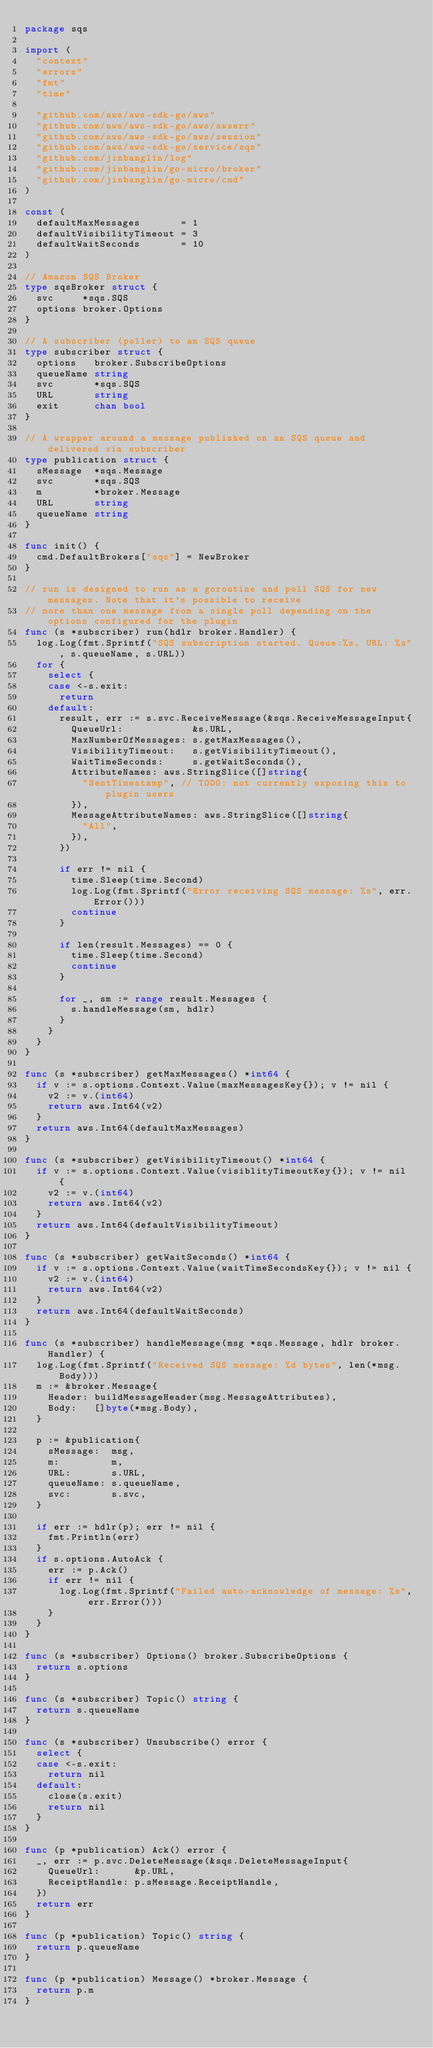Convert code to text. <code><loc_0><loc_0><loc_500><loc_500><_Go_>package sqs

import (
	"context"
	"errors"
	"fmt"
	"time"

	"github.com/aws/aws-sdk-go/aws"
	"github.com/aws/aws-sdk-go/aws/awserr"
	"github.com/aws/aws-sdk-go/aws/session"
	"github.com/aws/aws-sdk-go/service/sqs"
	"github.com/jinbanglin/log"
	"github.com/jinbanglin/go-micro/broker"
	"github.com/jinbanglin/go-micro/cmd"
)

const (
	defaultMaxMessages       = 1
	defaultVisibilityTimeout = 3
	defaultWaitSeconds       = 10
)

// Amazon SQS Broker
type sqsBroker struct {
	svc     *sqs.SQS
	options broker.Options
}

// A subscriber (poller) to an SQS queue
type subscriber struct {
	options   broker.SubscribeOptions
	queueName string
	svc       *sqs.SQS
	URL       string
	exit      chan bool
}

// A wrapper around a message published on an SQS queue and delivered via subscriber
type publication struct {
	sMessage  *sqs.Message
	svc       *sqs.SQS
	m         *broker.Message
	URL       string
	queueName string
}

func init() {
	cmd.DefaultBrokers["sqs"] = NewBroker
}

// run is designed to run as a goroutine and poll SQS for new messages. Note that it's possible to receive
// more than one message from a single poll depending on the options configured for the plugin
func (s *subscriber) run(hdlr broker.Handler) {
	log.Log(fmt.Sprintf("SQS subscription started. Queue:%s, URL: %s", s.queueName, s.URL))
	for {
		select {
		case <-s.exit:
			return
		default:
			result, err := s.svc.ReceiveMessage(&sqs.ReceiveMessageInput{
				QueueUrl:            &s.URL,
				MaxNumberOfMessages: s.getMaxMessages(),
				VisibilityTimeout:   s.getVisibilityTimeout(),
				WaitTimeSeconds:     s.getWaitSeconds(),
				AttributeNames: aws.StringSlice([]string{
					"SentTimestamp", // TODO: not currently exposing this to plugin users
				}),
				MessageAttributeNames: aws.StringSlice([]string{
					"All",
				}),
			})

			if err != nil {
				time.Sleep(time.Second)
				log.Log(fmt.Sprintf("Error receiving SQS message: %s", err.Error()))
				continue
			}

			if len(result.Messages) == 0 {
				time.Sleep(time.Second)
				continue
			}

			for _, sm := range result.Messages {
				s.handleMessage(sm, hdlr)
			}
		}
	}
}

func (s *subscriber) getMaxMessages() *int64 {
	if v := s.options.Context.Value(maxMessagesKey{}); v != nil {
		v2 := v.(int64)
		return aws.Int64(v2)
	}
	return aws.Int64(defaultMaxMessages)
}

func (s *subscriber) getVisibilityTimeout() *int64 {
	if v := s.options.Context.Value(visiblityTimeoutKey{}); v != nil {
		v2 := v.(int64)
		return aws.Int64(v2)
	}
	return aws.Int64(defaultVisibilityTimeout)
}

func (s *subscriber) getWaitSeconds() *int64 {
	if v := s.options.Context.Value(waitTimeSecondsKey{}); v != nil {
		v2 := v.(int64)
		return aws.Int64(v2)
	}
	return aws.Int64(defaultWaitSeconds)
}

func (s *subscriber) handleMessage(msg *sqs.Message, hdlr broker.Handler) {
	log.Log(fmt.Sprintf("Received SQS message: %d bytes", len(*msg.Body)))
	m := &broker.Message{
		Header: buildMessageHeader(msg.MessageAttributes),
		Body:   []byte(*msg.Body),
	}

	p := &publication{
		sMessage:  msg,
		m:         m,
		URL:       s.URL,
		queueName: s.queueName,
		svc:       s.svc,
	}

	if err := hdlr(p); err != nil {
		fmt.Println(err)
	}
	if s.options.AutoAck {
		err := p.Ack()
		if err != nil {
			log.Log(fmt.Sprintf("Failed auto-acknowledge of message: %s", err.Error()))
		}
	}
}

func (s *subscriber) Options() broker.SubscribeOptions {
	return s.options
}

func (s *subscriber) Topic() string {
	return s.queueName
}

func (s *subscriber) Unsubscribe() error {
	select {
	case <-s.exit:
		return nil
	default:
		close(s.exit)
		return nil
	}
}

func (p *publication) Ack() error {
	_, err := p.svc.DeleteMessage(&sqs.DeleteMessageInput{
		QueueUrl:      &p.URL,
		ReceiptHandle: p.sMessage.ReceiptHandle,
	})
	return err
}

func (p *publication) Topic() string {
	return p.queueName
}

func (p *publication) Message() *broker.Message {
	return p.m
}
</code> 